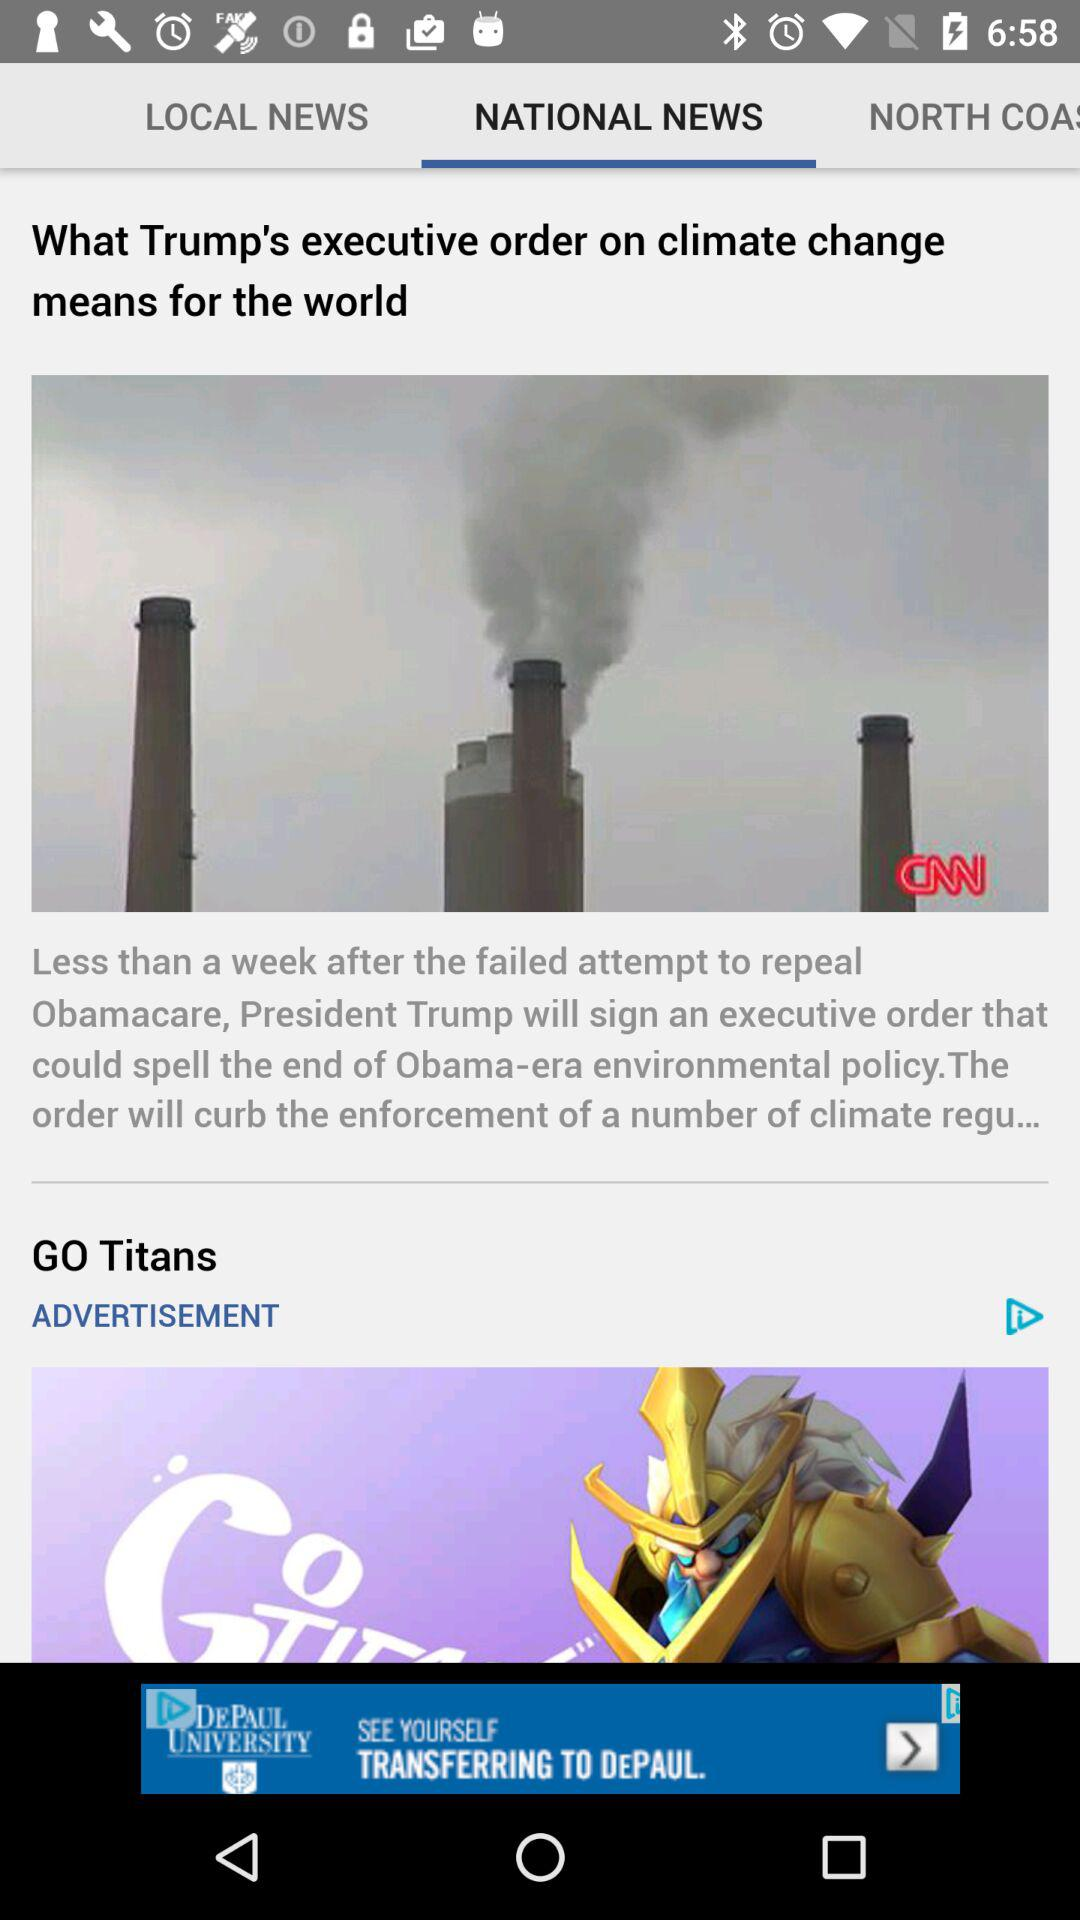Which tab is selected? The selected tab is "NATIONAL NEWS". 